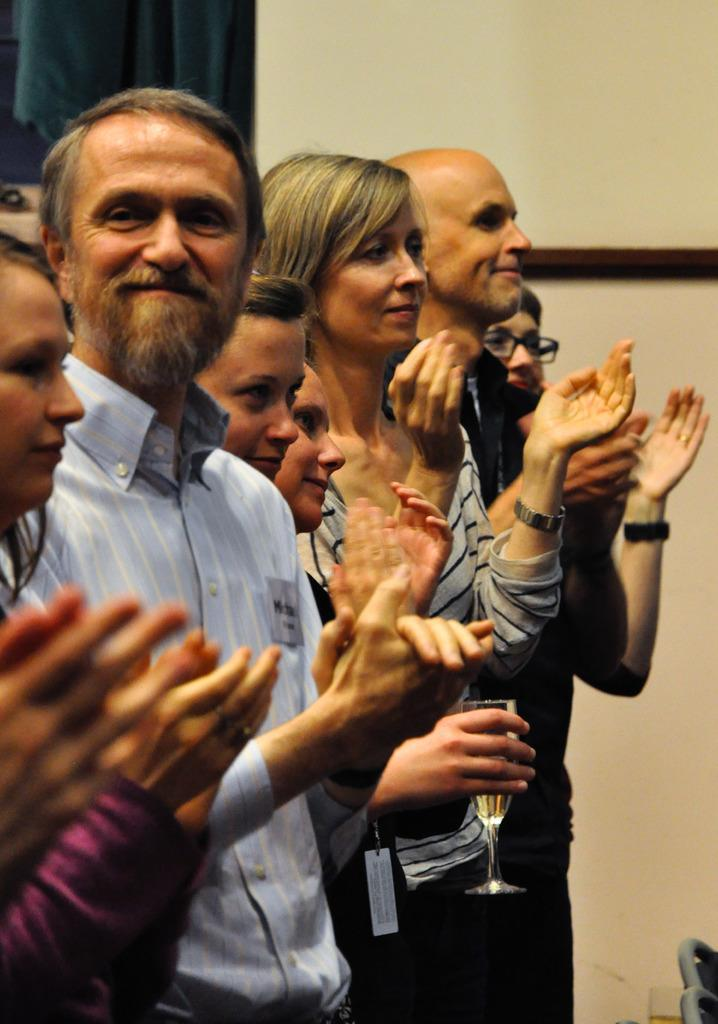What are the people in the image doing? The people in the image are standing and clapping their hands. Can you describe the action of one of the people in the image? There is a person holding a glass in the image. What can be seen in the background of the image? There is a curtain and a wall in the background of the image. What type of ornament is hanging from the wall in the image? There is no ornament hanging from the wall in the image; only a curtain and a wall are present. Can you read the note that one of the people is holding in the image? There is no note visible in the image; only people clapping, a person holding a glass, and a curtain and wall in the background are present. 